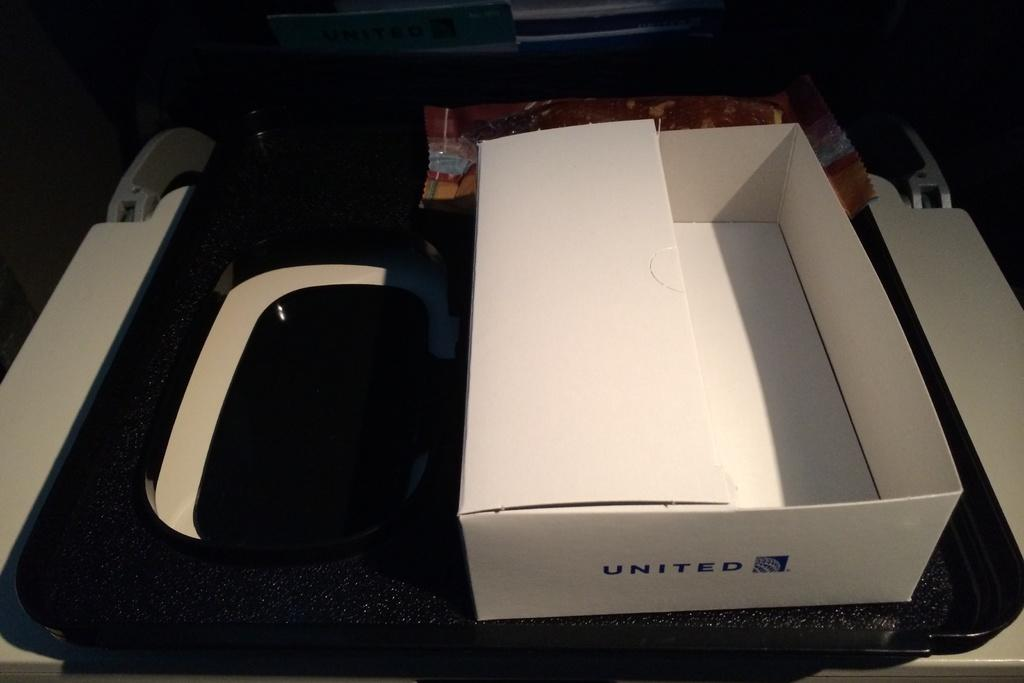<image>
Describe the image concisely. A white box setting in a tray with united on the front. 